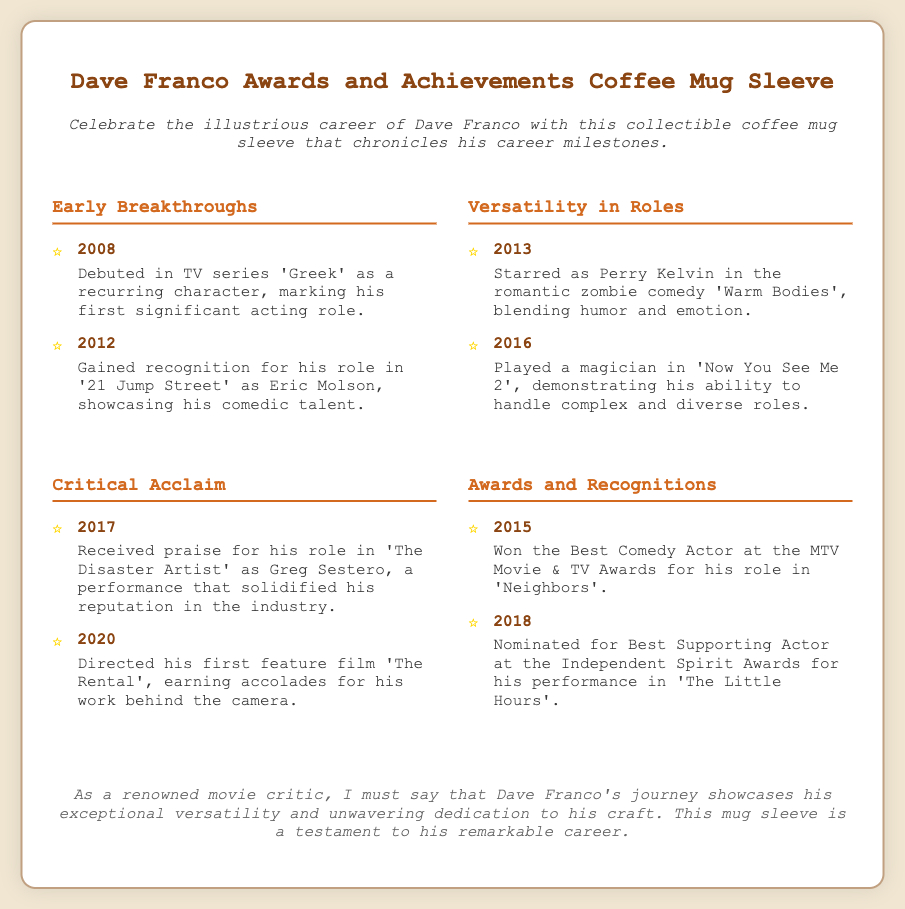What role did Dave Franco debut in 2008? The document states that he debuted in the TV series 'Greek' as a recurring character.
Answer: Greek What movie showcased Dave Franco's comedic talent? The document mentions that he gained recognition for his role in '21 Jump Street'.
Answer: 21 Jump Street In which romantic zombie comedy did he star in 2013? According to the document, he starred as Perry Kelvin in 'Warm Bodies'.
Answer: Warm Bodies What accolade did Franco win in 2015? The document indicates that he won the Best Comedy Actor at the MTV Movie & TV Awards for his role in 'Neighbors'.
Answer: Best Comedy Actor Which film did he direct in 2020? The document notes that he directed his first feature film 'The Rental' in 2020.
Answer: The Rental What year was he nominated for Best Supporting Actor at the Independent Spirit Awards? The document specifies that he was nominated in 2018 for 'The Little Hours'.
Answer: 2018 What milestone solidified his reputation in the industry? The document states that his role in 'The Disaster Artist' received praise, solidifying his reputation.
Answer: The Disaster Artist What type of item is being described in the document? The document describes a collectible coffee mug sleeve chronicling Dave Franco's career milestones.
Answer: Coffee mug sleeve What is emphasized in the critic's note about Dave Franco's journey? The critic's note highlights his exceptional versatility and unwavering dedication to his craft.
Answer: Exceptional versatility 